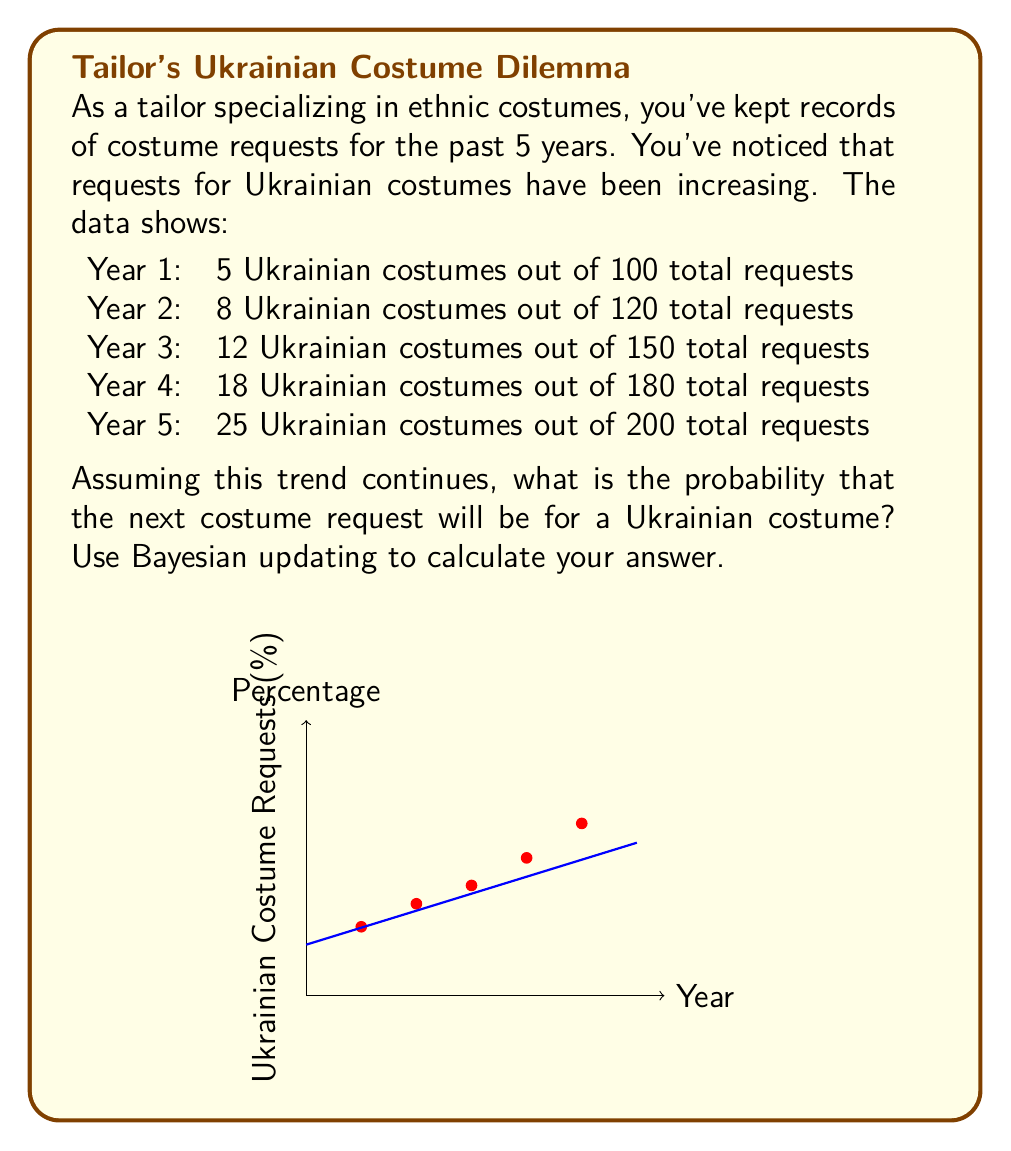Give your solution to this math problem. To solve this problem using Bayesian updating, we'll follow these steps:

1) First, let's calculate the prior probability based on the overall data:
   Total Ukrainian costumes = 5 + 8 + 12 + 18 + 25 = 68
   Total requests = 100 + 120 + 150 + 180 + 200 = 750
   Prior probability = 68 / 750 = 0.0907 or 9.07%

2) Now, we'll use the trend to update our prior. We can see that the percentage is increasing each year:
   Year 1: 5% (5/100)
   Year 2: 6.67% (8/120)
   Year 3: 8% (12/150)
   Year 4: 10% (18/180)
   Year 5: 12.5% (25/200)

3) To predict the next year, we can use a simple linear regression. The slope of the line is:
   $\text{slope} = \frac{12.5\% - 5\%}{5 - 1} = 1.875\%$ per year

4) For Year 6, we'd expect:
   $12.5\% + 1.875\% = 14.375\%$

5) Now we can use Bayes' theorem to update our prior:

   $$P(A|B) = \frac{P(B|A) \cdot P(A)}{P(B)}$$

   Where:
   A = Next request is Ukrainian costume
   B = Observed trend
   P(A) = Prior probability = 0.0907
   P(B|A) = Likelihood of trend given it's Ukrainian = 0.14375
   P(B) = Overall probability of trend = 0.14375 * 0.0907 + (1-0.14375) * (1-0.0907) = 0.8669

6) Plugging into Bayes' theorem:

   $$P(A|B) = \frac{0.14375 \cdot 0.0907}{0.8669} = 0.1501$$

Therefore, the updated probability is approximately 15.01%.
Answer: 15.01% 